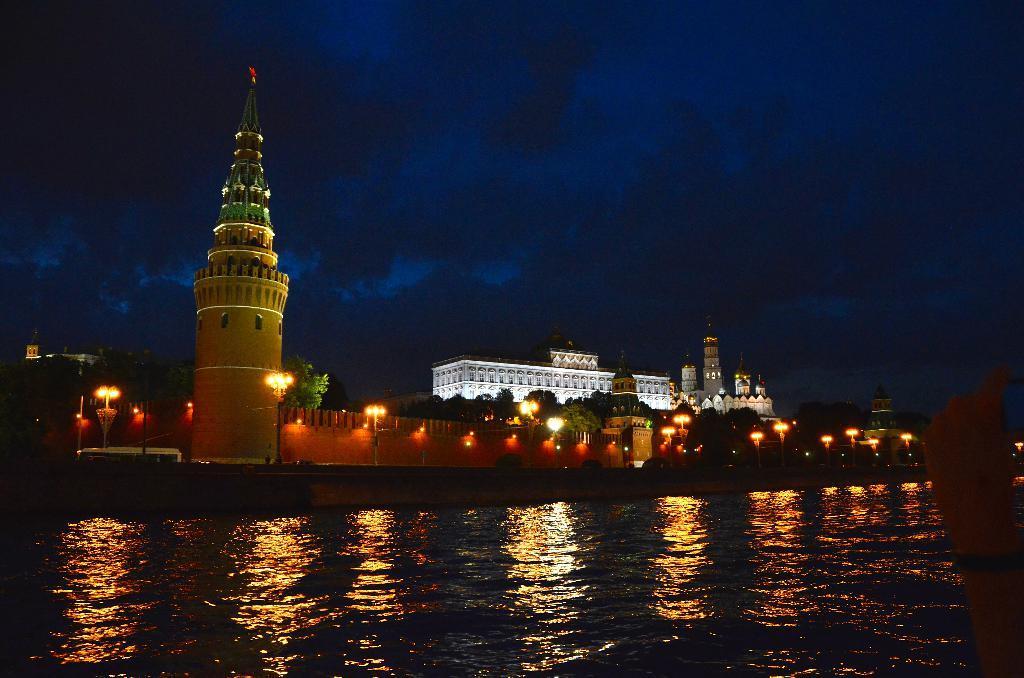Describe this image in one or two sentences. Front we can see water. Background there is a building, lights and trees. 